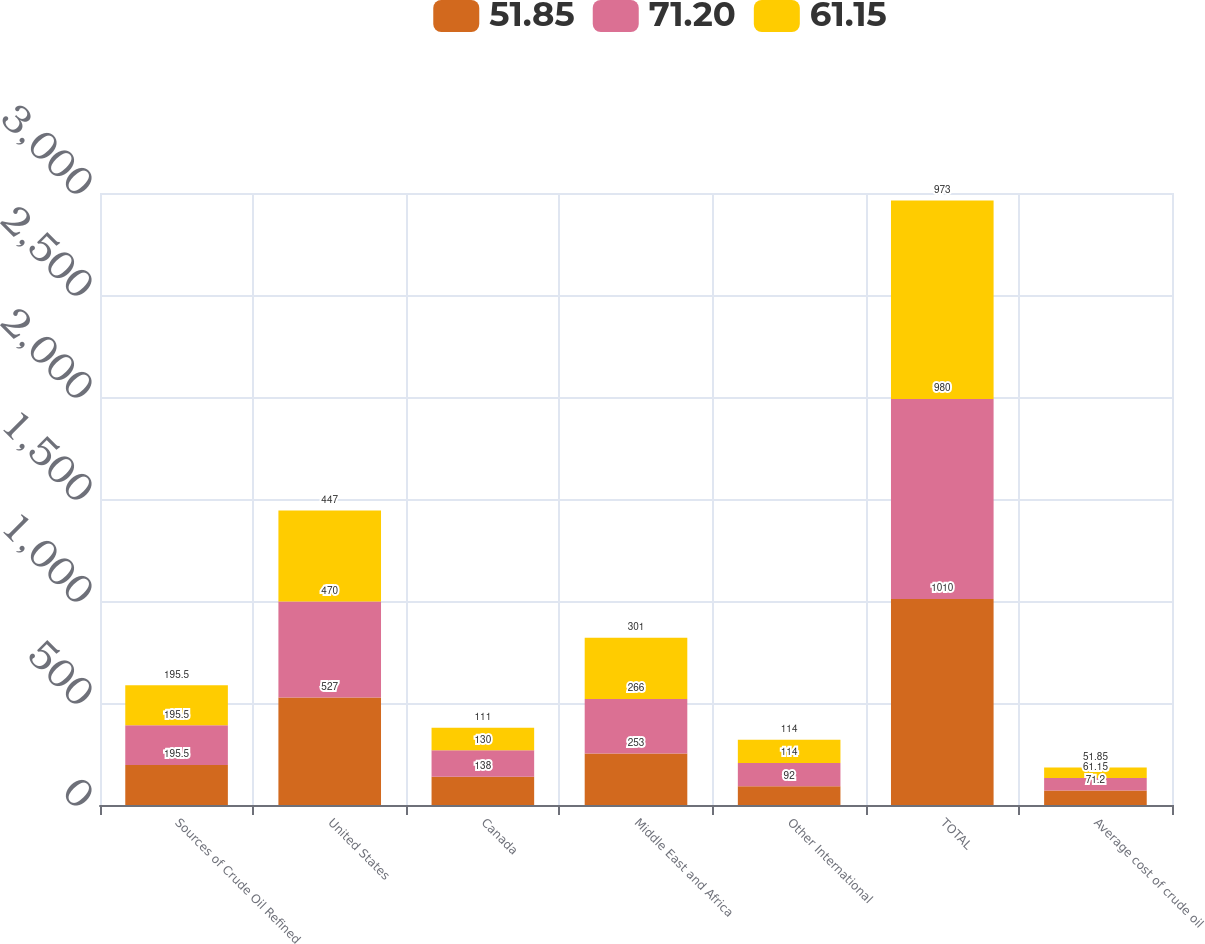Convert chart. <chart><loc_0><loc_0><loc_500><loc_500><stacked_bar_chart><ecel><fcel>Sources of Crude Oil Refined<fcel>United States<fcel>Canada<fcel>Middle East and Africa<fcel>Other International<fcel>TOTAL<fcel>Average cost of crude oil<nl><fcel>51.85<fcel>195.5<fcel>527<fcel>138<fcel>253<fcel>92<fcel>1010<fcel>71.2<nl><fcel>71.2<fcel>195.5<fcel>470<fcel>130<fcel>266<fcel>114<fcel>980<fcel>61.15<nl><fcel>61.15<fcel>195.5<fcel>447<fcel>111<fcel>301<fcel>114<fcel>973<fcel>51.85<nl></chart> 